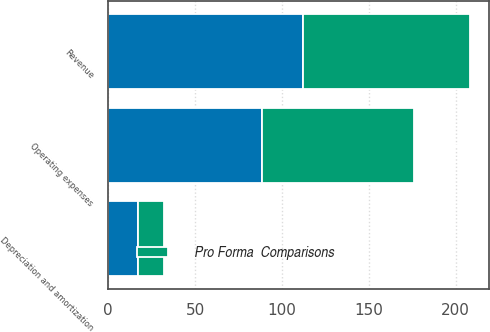<chart> <loc_0><loc_0><loc_500><loc_500><stacked_bar_chart><ecel><fcel>Revenue<fcel>Operating expenses<fcel>Depreciation and amortization<nl><fcel>nan<fcel>111.9<fcel>88.7<fcel>17.2<nl><fcel>Pro Forma  Comparisons<fcel>96.6<fcel>87.5<fcel>15<nl></chart> 